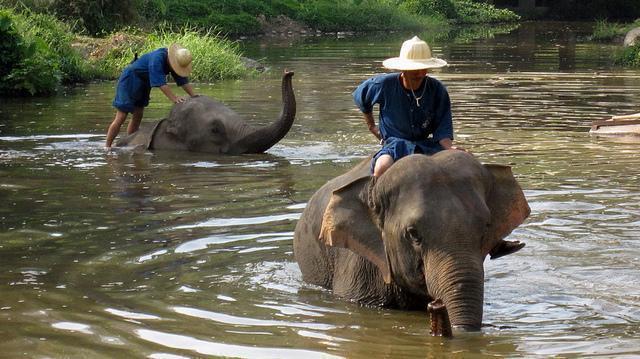What are the hats the men are wearing called?
Select the correct answer and articulate reasoning with the following format: 'Answer: answer
Rationale: rationale.'
Options: Baseball caps, derby hats, safari hats, top hats. Answer: safari hats.
Rationale: The men are wearing hats on a safari. 